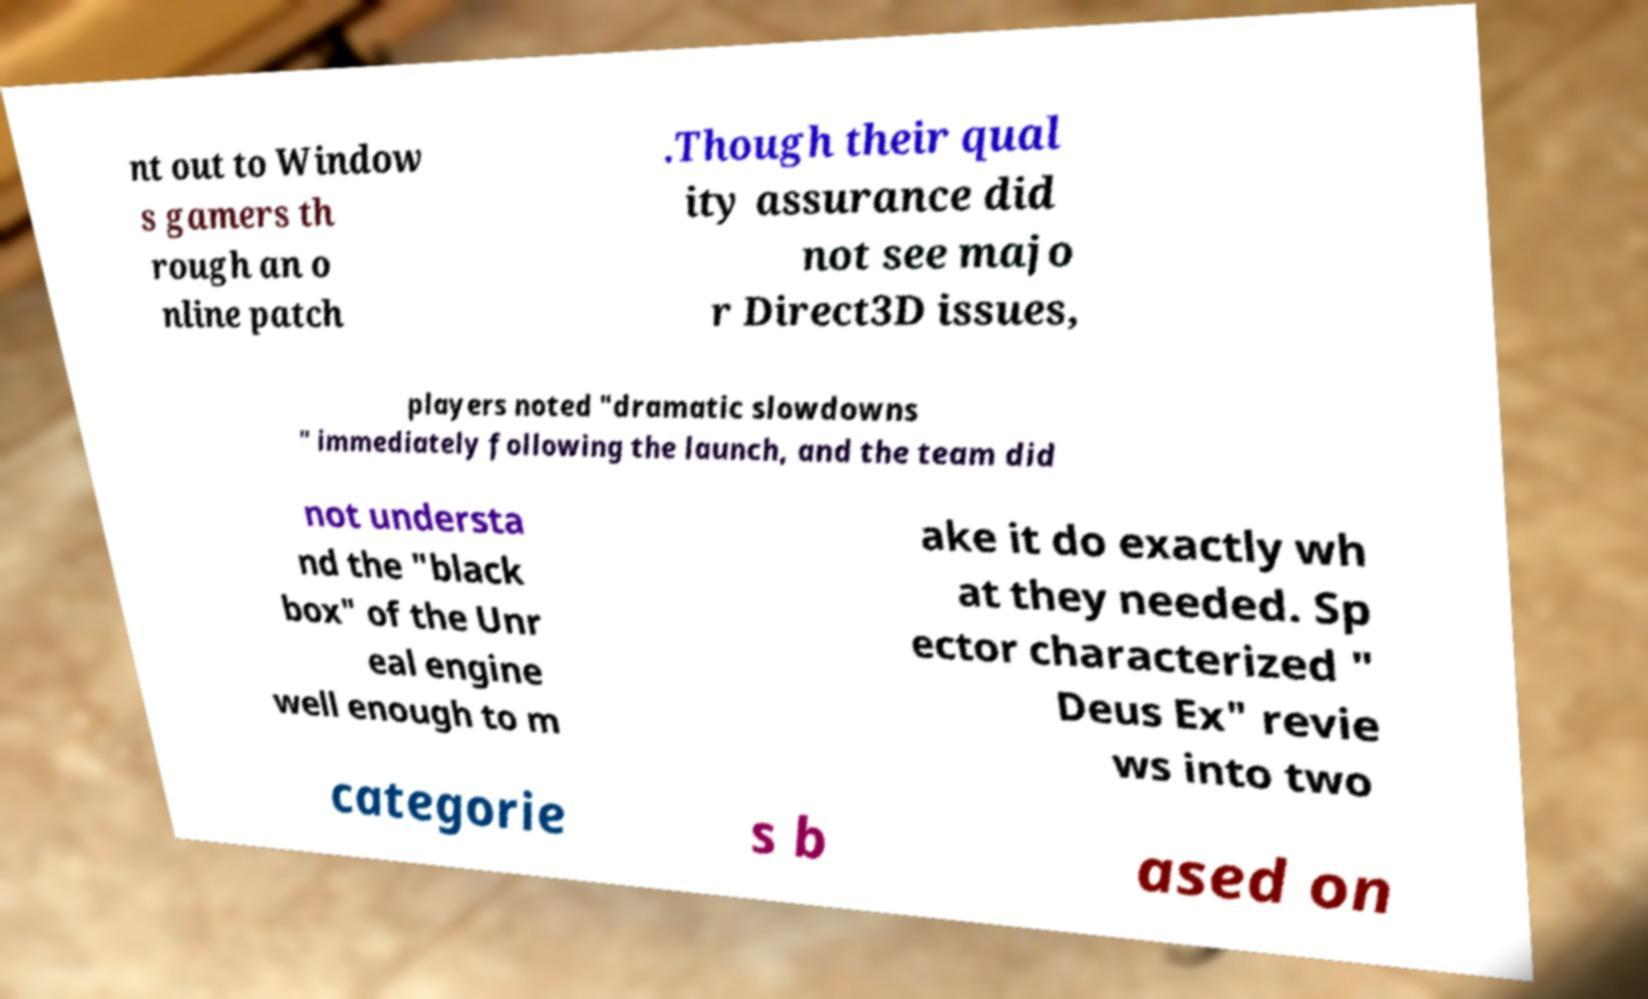Could you assist in decoding the text presented in this image and type it out clearly? nt out to Window s gamers th rough an o nline patch .Though their qual ity assurance did not see majo r Direct3D issues, players noted "dramatic slowdowns " immediately following the launch, and the team did not understa nd the "black box" of the Unr eal engine well enough to m ake it do exactly wh at they needed. Sp ector characterized " Deus Ex" revie ws into two categorie s b ased on 